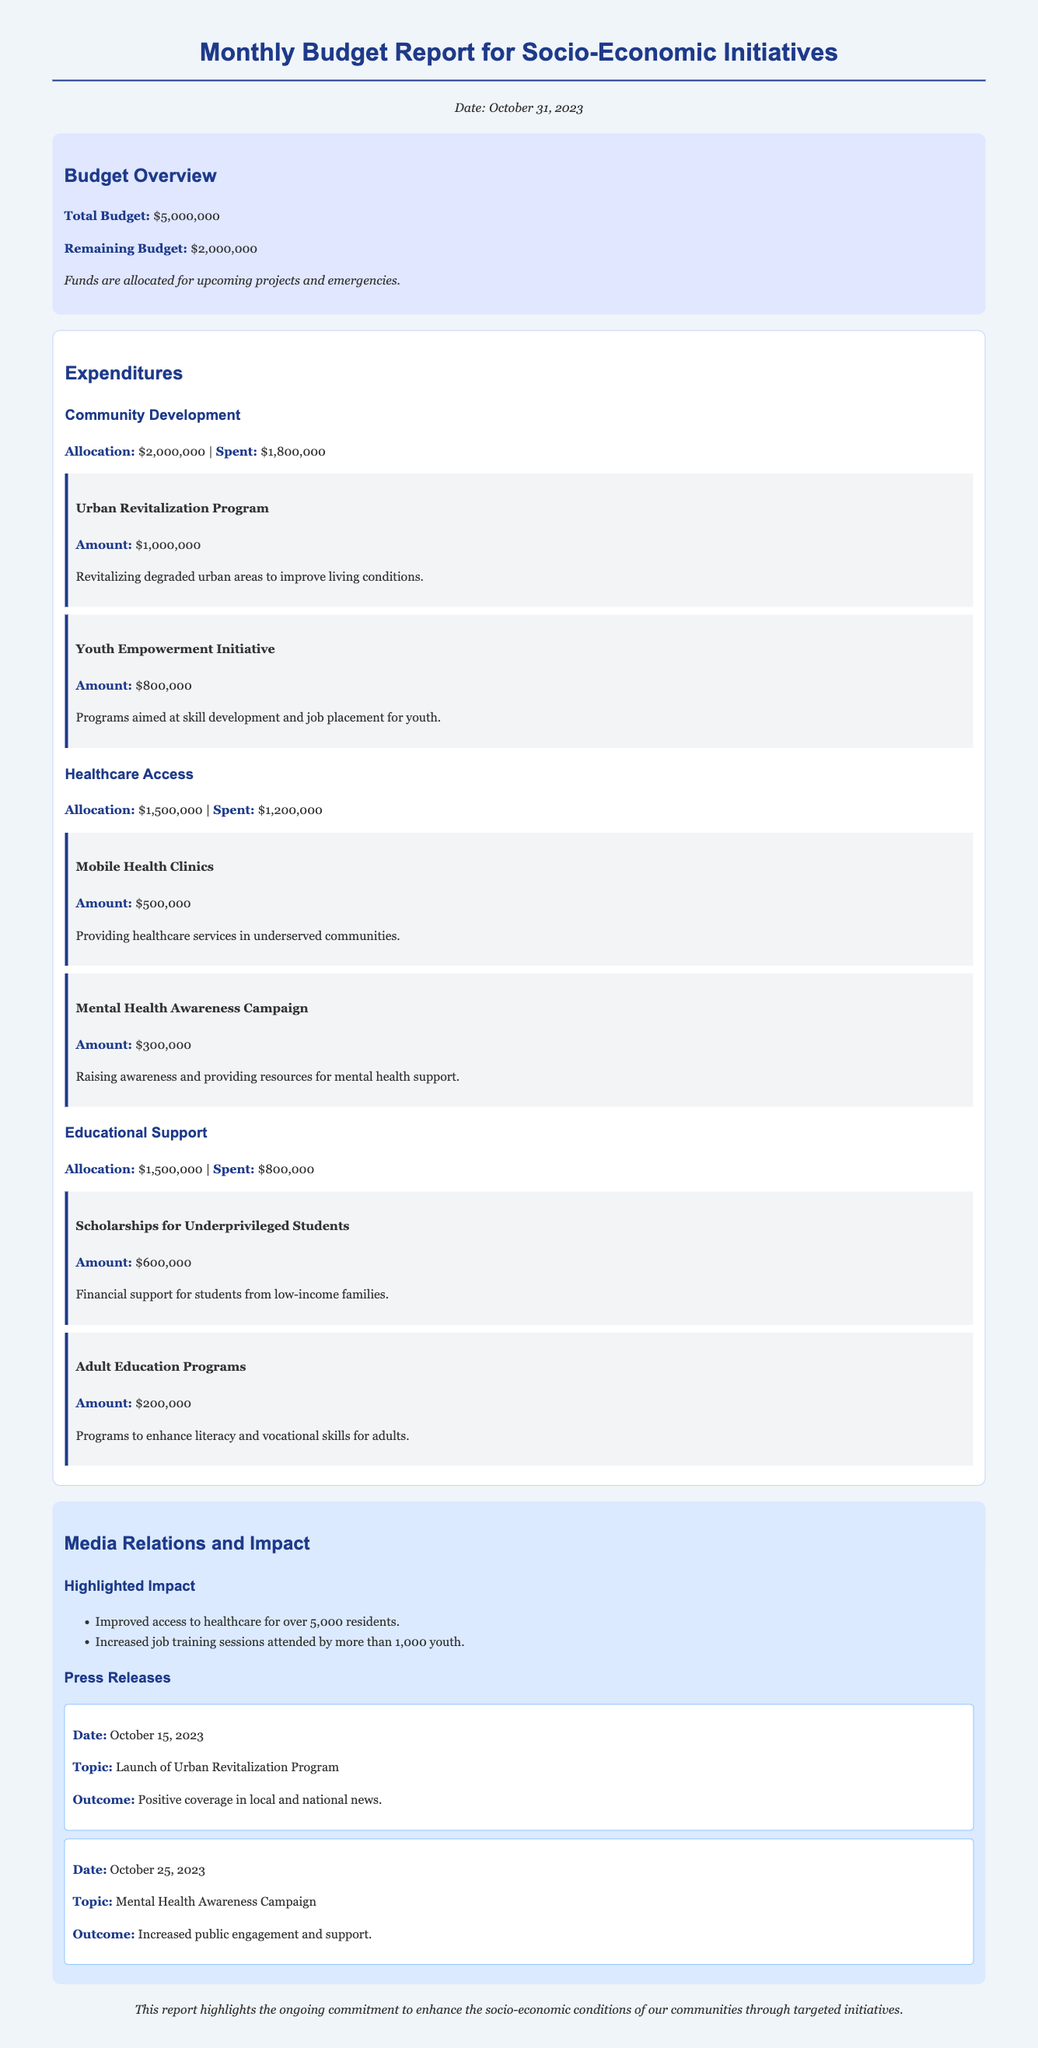What is the total budget? The total budget is stated at the top of the budget overview section.
Answer: $5,000,000 What is the remaining budget? The remaining budget is also provided in the budget overview section.
Answer: $2,000,000 How much was allocated for the Healthcare Access initiative? The allocation for Healthcare Access can be found in its respective section.
Answer: $1,500,000 How much has been spent on Community Development? The expenditure amount is listed under the Community Development section.
Answer: $1,800,000 What project received the highest funding? The project with the highest funding is detailed in the Community Development section.
Answer: Urban Revitalization Program How many residents improved healthcare access? The number of residents highlighted is mentioned in the media relations section.
Answer: Over 5,000 What was the outcome of the Urban Revitalization Program press release? The outcome is noted in the respective press release section.
Answer: Positive coverage in local and national news What is the topic of the press release dated October 25, 2023? The specific press release date and topic are listed in the media section.
Answer: Mental Health Awareness Campaign How much funding was allocated to Scholarships for Underprivileged Students? The funding amount for this project is specified in its project detail.
Answer: $600,000 